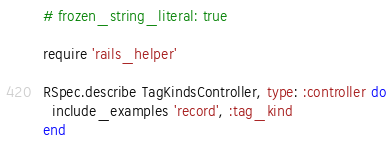Convert code to text. <code><loc_0><loc_0><loc_500><loc_500><_Ruby_># frozen_string_literal: true

require 'rails_helper'

RSpec.describe TagKindsController, type: :controller do
  include_examples 'record', :tag_kind
end
</code> 